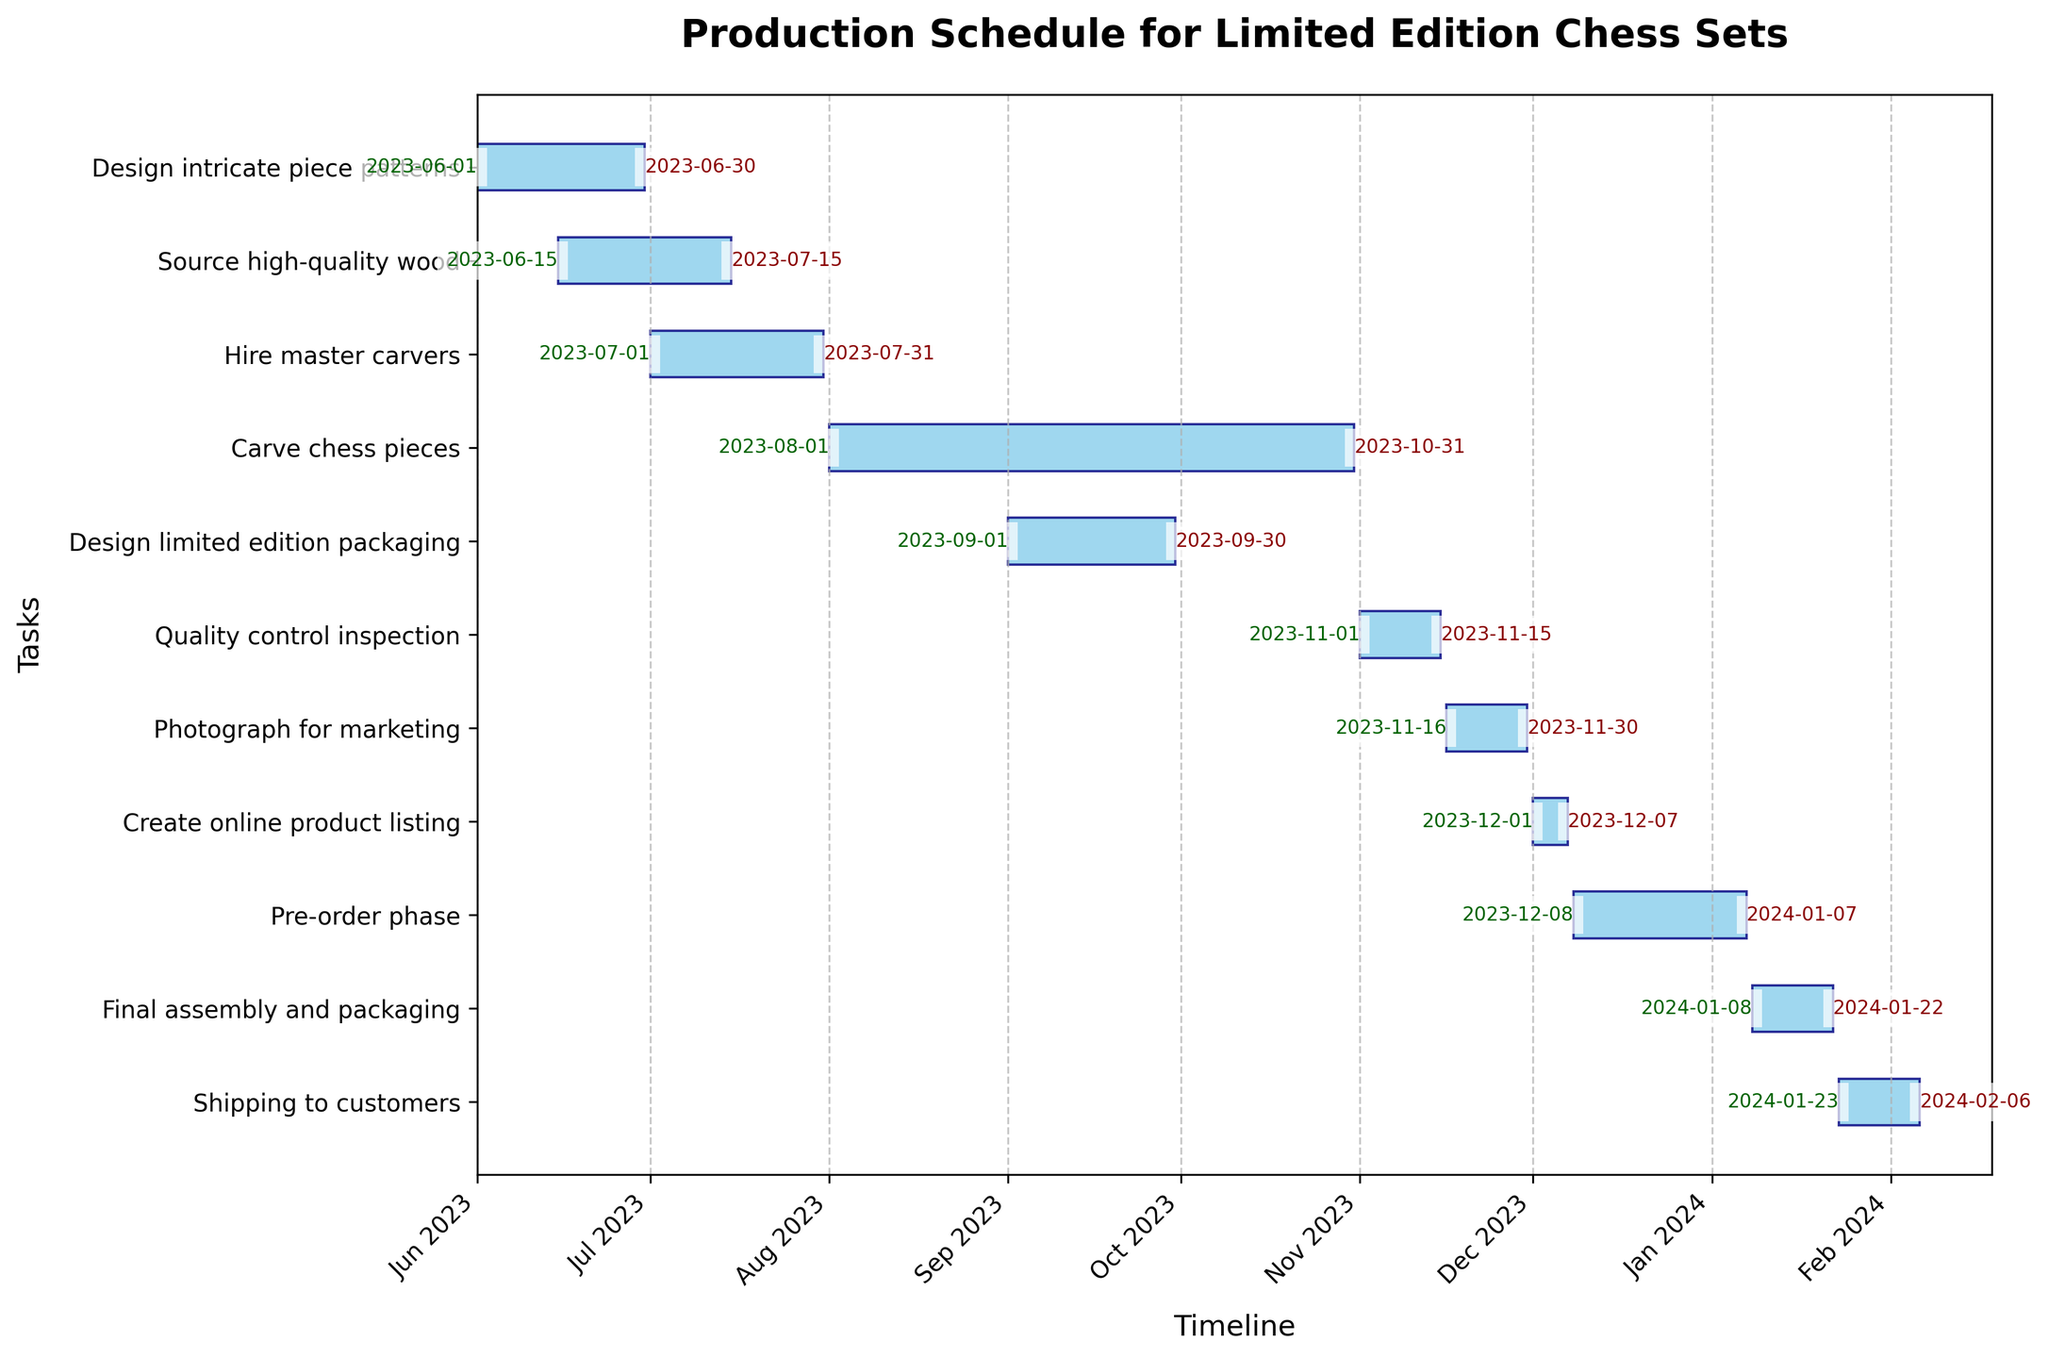When does the “Carve chess pieces” task start and end? The start and end dates are displayed on the Gantt chart for each task. For the “Carve chess pieces” task, the start date is shown as 2023-08-01 and the end date as 2023-10-31.
Answer: 2023-08-01 to 2023-10-31 Which task takes the longest time to complete? By observing the length of the bars in the Gantt chart, the “Carve chess pieces” task has the longest duration as the bar is extended further on the timeline compared to others.
Answer: Carve chess pieces Are there any tasks that overlap with “Source high-quality wood”? “Source high-quality wood” runs from 2023-06-15 to 2023-07-15. Overlapping tasks are those whose bars intersect with this timeframe. The tasks that overlap are “Design intricate piece patterns” and “Hire master carvers”.
Answer: Design intricate piece patterns, Hire master carvers How many tasks are scheduled to start in July 2023? The Gantt chart shows the task start dates. By counting the tasks starting in July, “Hire master carvers” is the only task that starts in that month.
Answer: 1 What is the total duration from the start of the first task to the end of the last task? The first task starts on 2023-06-01 and the last task ends on 2024-02-06. To find the duration, calculate the days between these dates. The duration from 2023-06-01 to 2024-02-06 is 251 days.
Answer: 251 days Does the “Quality control inspection” task overlap with any tasks? The “Quality control inspection” runs from 2023-11-01 to 2023-11-15. We need to check the tasks that fall within these dates. The overlapping task is “Photograph for marketing”.
Answer: Photograph for marketing Which task directly follows “Create online product listing”? Looking at the end date of “Create online product listing” which is 2023-12-07, the next task that starts immediately after is “Pre-order phase” on 2023-12-08.
Answer: Pre-order phase 